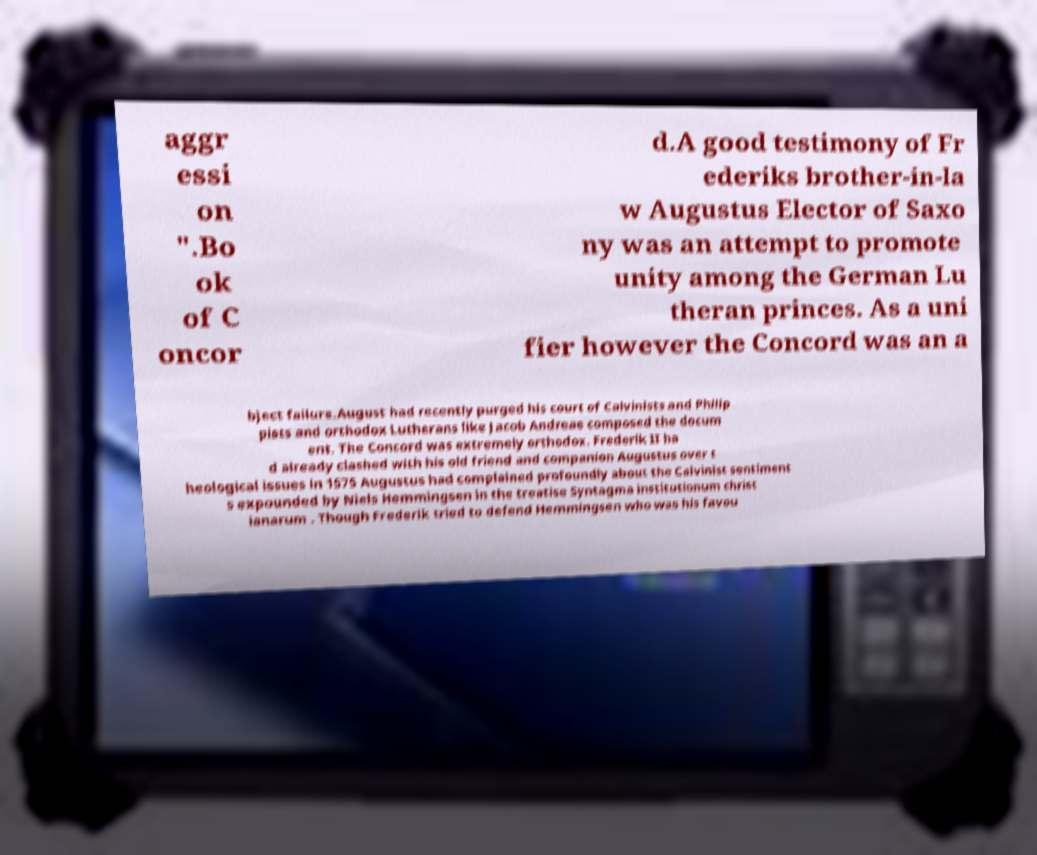Please read and relay the text visible in this image. What does it say? aggr essi on ".Bo ok of C oncor d.A good testimony of Fr ederiks brother-in-la w Augustus Elector of Saxo ny was an attempt to promote unity among the German Lu theran princes. As a uni fier however the Concord was an a bject failure.August had recently purged his court of Calvinists and Philip pists and orthodox Lutherans like Jacob Andreae composed the docum ent. The Concord was extremely orthodox. Frederik II ha d already clashed with his old friend and companion Augustus over t heological issues in 1575 Augustus had complained profoundly about the Calvinist sentiment s expounded by Niels Hemmingsen in the treatise Syntagma institutionum christ ianarum . Though Frederik tried to defend Hemmingsen who was his favou 